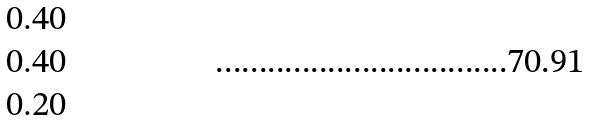<formula> <loc_0><loc_0><loc_500><loc_500>\begin{matrix} 0 . 4 0 \\ 0 . 4 0 \\ 0 . 2 0 \\ \end{matrix}</formula> 